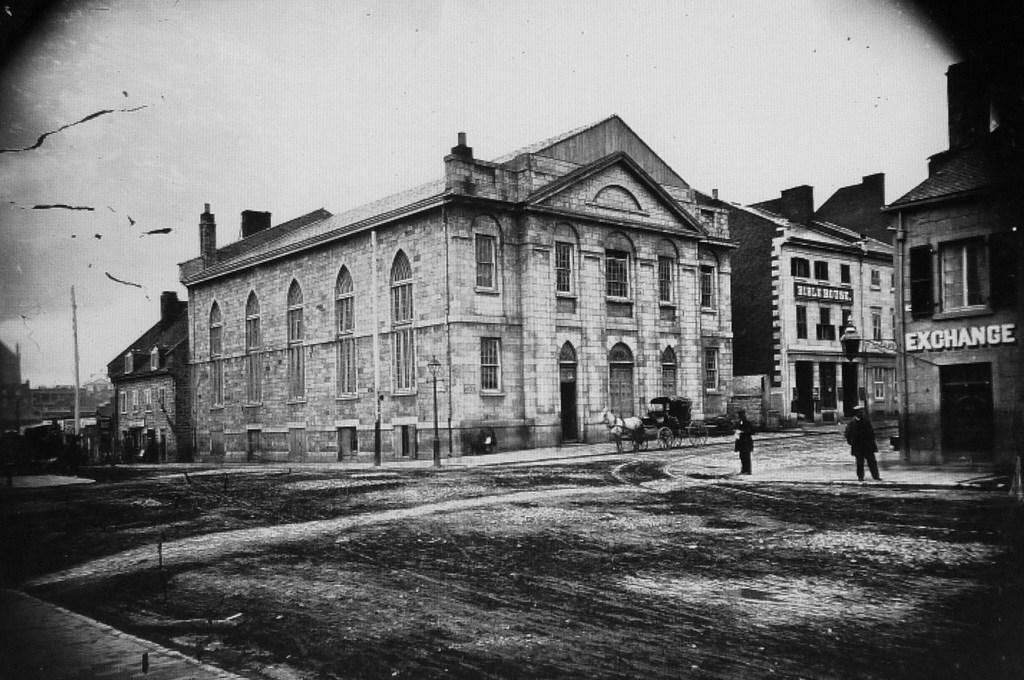What is the color scheme of the image? The image is black and white. What type of structures can be seen in the image? There are buildings in the image. What other objects are present in the image? There are poles and vehicles in the image. Are there any living beings in the image? Yes, there are people in the image. What is the primary surface visible in the image? There is a road at the bottom of the image. What type of vessel is being used to say good-bye in the image? There is no vessel or good-bye gesture present in the image. 